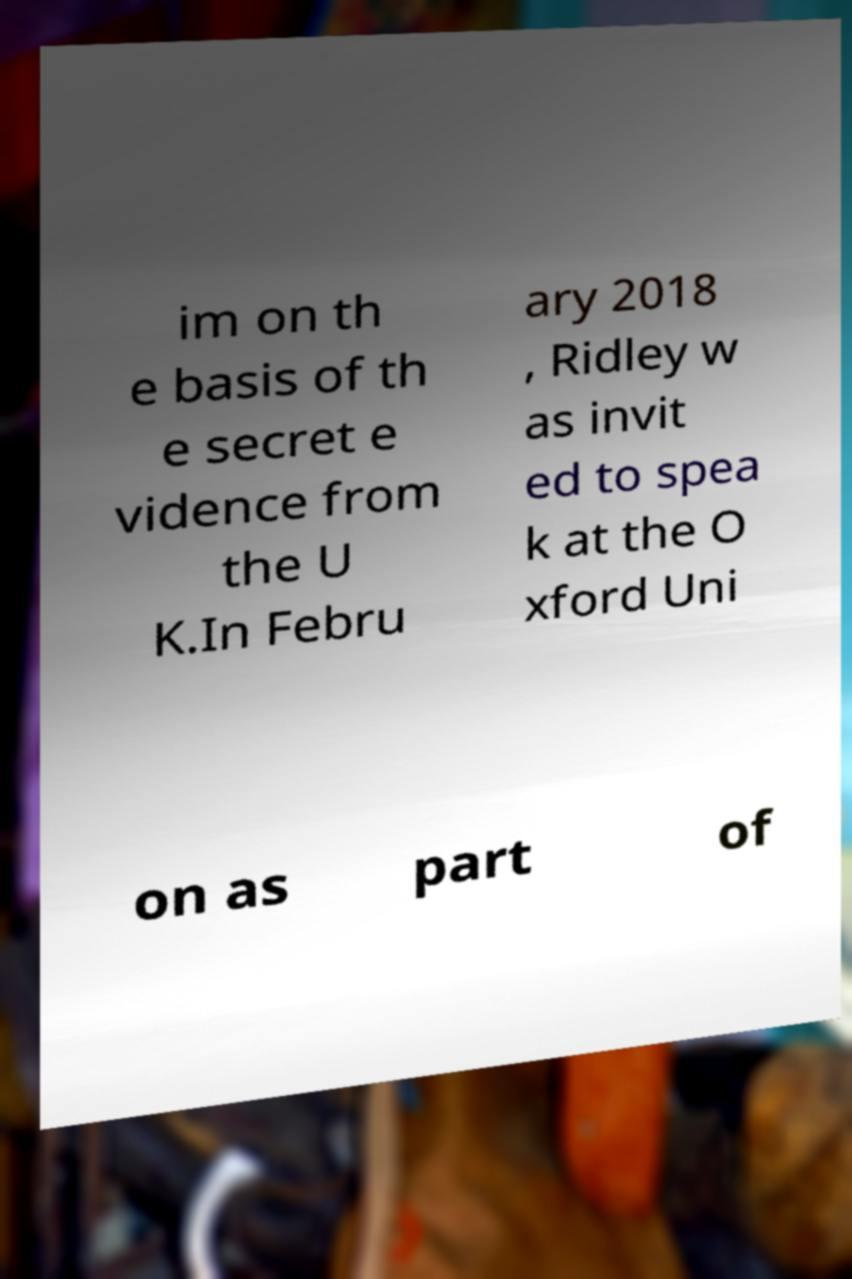There's text embedded in this image that I need extracted. Can you transcribe it verbatim? im on th e basis of th e secret e vidence from the U K.In Febru ary 2018 , Ridley w as invit ed to spea k at the O xford Uni on as part of 